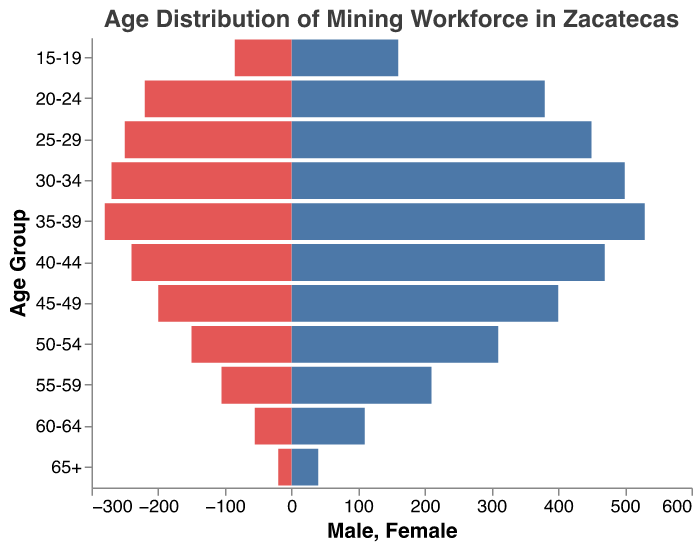What is the largest age group for both males and females in the mining workforce? The largest age group is determined by finding the age group with the tallest bars in both the male and female categories. For males, the age group 35-39 has the highest value, and for females, the same age group 35-39 also has the highest value.
Answer: 35-39 How does the number of skilled males compare to unskilled males in the 30-34 age group? The number of skilled males in the 30-34 age group is 300, while the number of unskilled males in this age group is 200. Subtracting these values, we find that there are 100 more skilled males than unskilled males in this age group.
Answer: 100 more skilled males Which age group has the highest number of unskilled females? To find this, check the bars for unskilled females and identify the tallest one. The age group 20-24 has the highest value with 180 unskilled females.
Answer: 20-24 What is the total number of people in the 55-59 age group? Add the values for each demographic in the 55-59 age group: 150 skilled males, 75 skilled females, 60 unskilled males, and 30 unskilled females. 150 + 75 + 60 + 30 = 315.
Answer: 315 How does the distribution of skilled versus unskilled labor change with age? Observing the plot, younger age groups (e.g., 15-24) show a larger proportion of unskilled labor, while older age groups (e.g., 30-49) have a higher proportion of skilled labor. This trend suggests a shift towards higher skill levels as age increases.
Answer: More skilled labor in older age groups In which age group is the difference between skilled males and skilled females the smallest? Calculate the difference for each age group and identify the smallest difference. For the age group 15-19, the difference is 5; for 20-24, it’s 40, and so on. The age group 55-59 has a difference of 75 - 30 = 45, which is the smallest among all.
Answer: 15-19 What is the ratio of skilled males to skilled females in the 45-49 age group? Divide the number of skilled males by the number of skilled females in this age group: 280 skilled males divided by 140 skilled females equals a ratio of 2:1.
Answer: 2:1 Which gender has a smaller absolute number in the 65+ age group and by how much? Compare the values for males and females in the 65+ age group: 30 skilled males + 10 unskilled males = 40, and 15 skilled females + 5 unskilled females = 20. Therefore, females have fewer members in this age group by 40 - 20 = 20.
Answer: Females, by 20 How does the total number of skilled workers compare between the 20-24 and 40-44 age groups? Calculate the total number of skilled workers for both age groups and compare. For 20-24: 80 skilled males + 40 skilled females = 120. For 40-44: 320 skilled males + 160 skilled females = 480. Thus, 480 - 120 = 360 more skilled workers in the 40-44 age group.
Answer: 360 more skilled workers in 40-44 